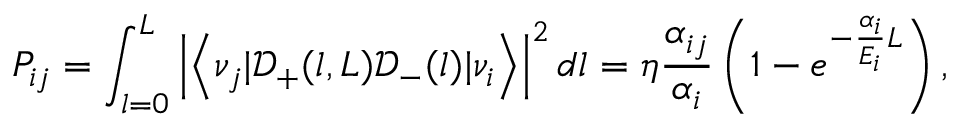<formula> <loc_0><loc_0><loc_500><loc_500>P _ { i j } = \int _ { l = 0 } ^ { L } \left | \left < \nu _ { j } | \mathcal { D } _ { + } ( l , L ) \mathcal { D } _ { - } ( l ) | \nu _ { i } \right > \right | ^ { 2 } d l = \eta \frac { \alpha _ { i j } } { \alpha _ { i } } \left ( 1 - e ^ { - \frac { \alpha _ { i } } { E _ { i } } L } \right ) ,</formula> 